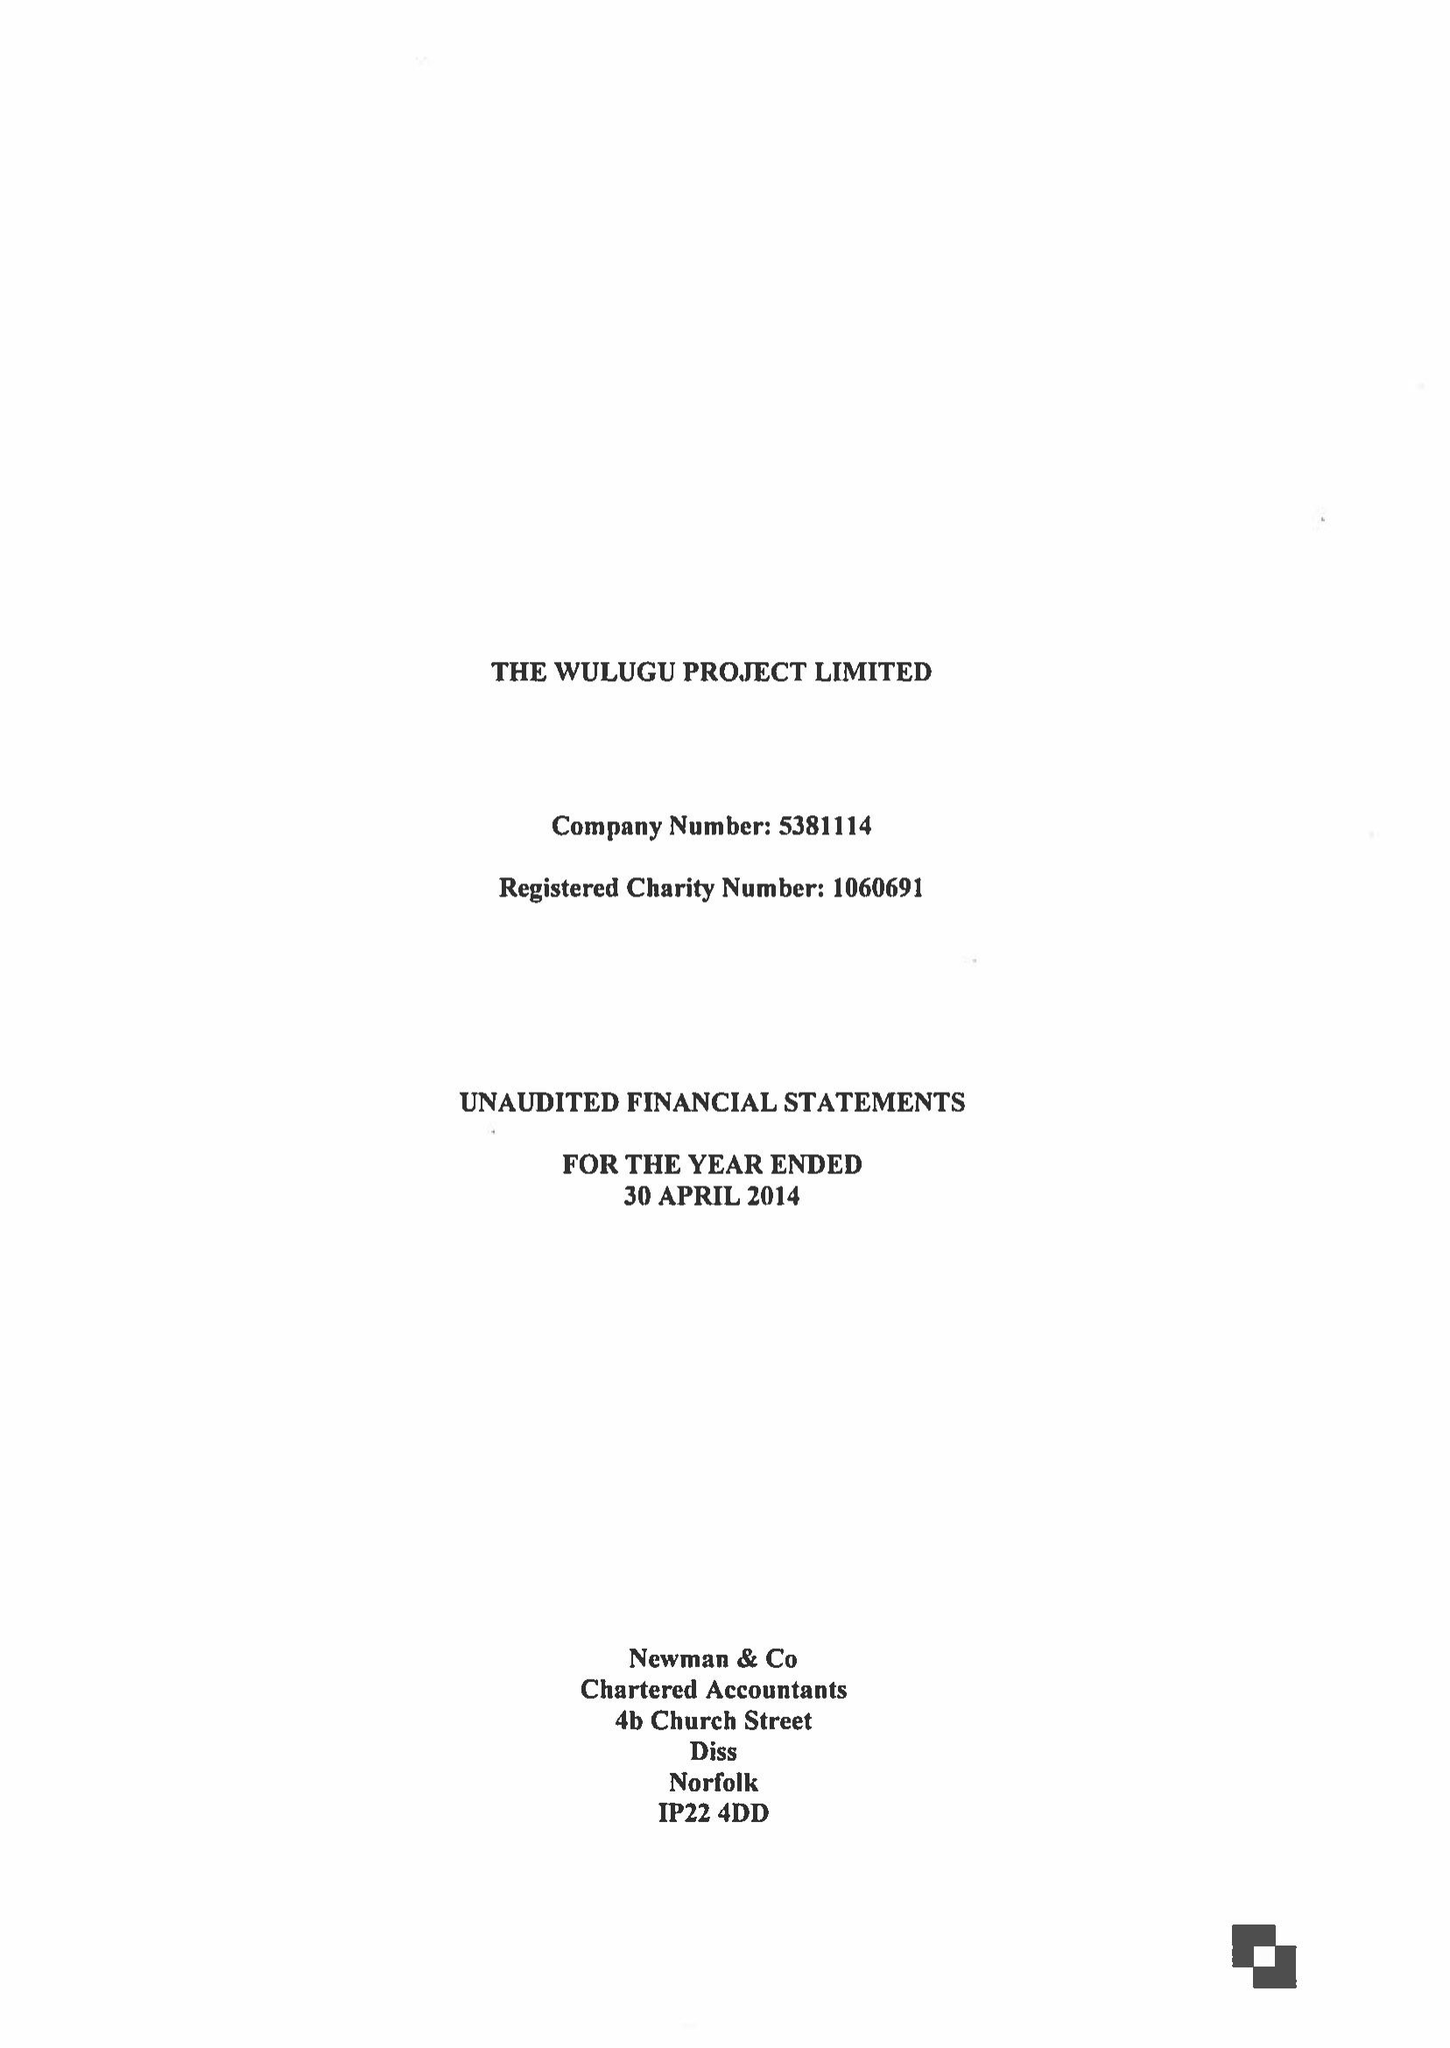What is the value for the address__post_town?
Answer the question using a single word or phrase. NORWICH 